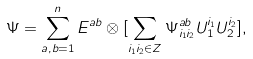Convert formula to latex. <formula><loc_0><loc_0><loc_500><loc_500>\Psi = \sum _ { a , b = 1 } ^ { n } E ^ { a b } \otimes [ \sum _ { i _ { 1 } i _ { 2 } \in { Z } } \Psi ^ { a b } _ { i _ { 1 } i _ { 2 } } U _ { 1 } ^ { i _ { 1 } } U _ { 2 } ^ { i _ { 2 } } ] ,</formula> 